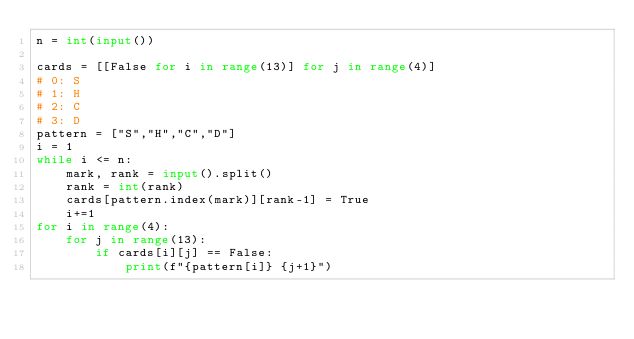<code> <loc_0><loc_0><loc_500><loc_500><_Python_>n = int(input())

cards = [[False for i in range(13)] for j in range(4)]
# 0: S
# 1: H
# 2: C
# 3: D
pattern = ["S","H","C","D"]
i = 1
while i <= n:    
    mark, rank = input().split()
    rank = int(rank)
    cards[pattern.index(mark)][rank-1] = True
    i+=1
for i in range(4):
    for j in range(13):
        if cards[i][j] == False:
            print(f"{pattern[i]} {j+1}") 


</code> 